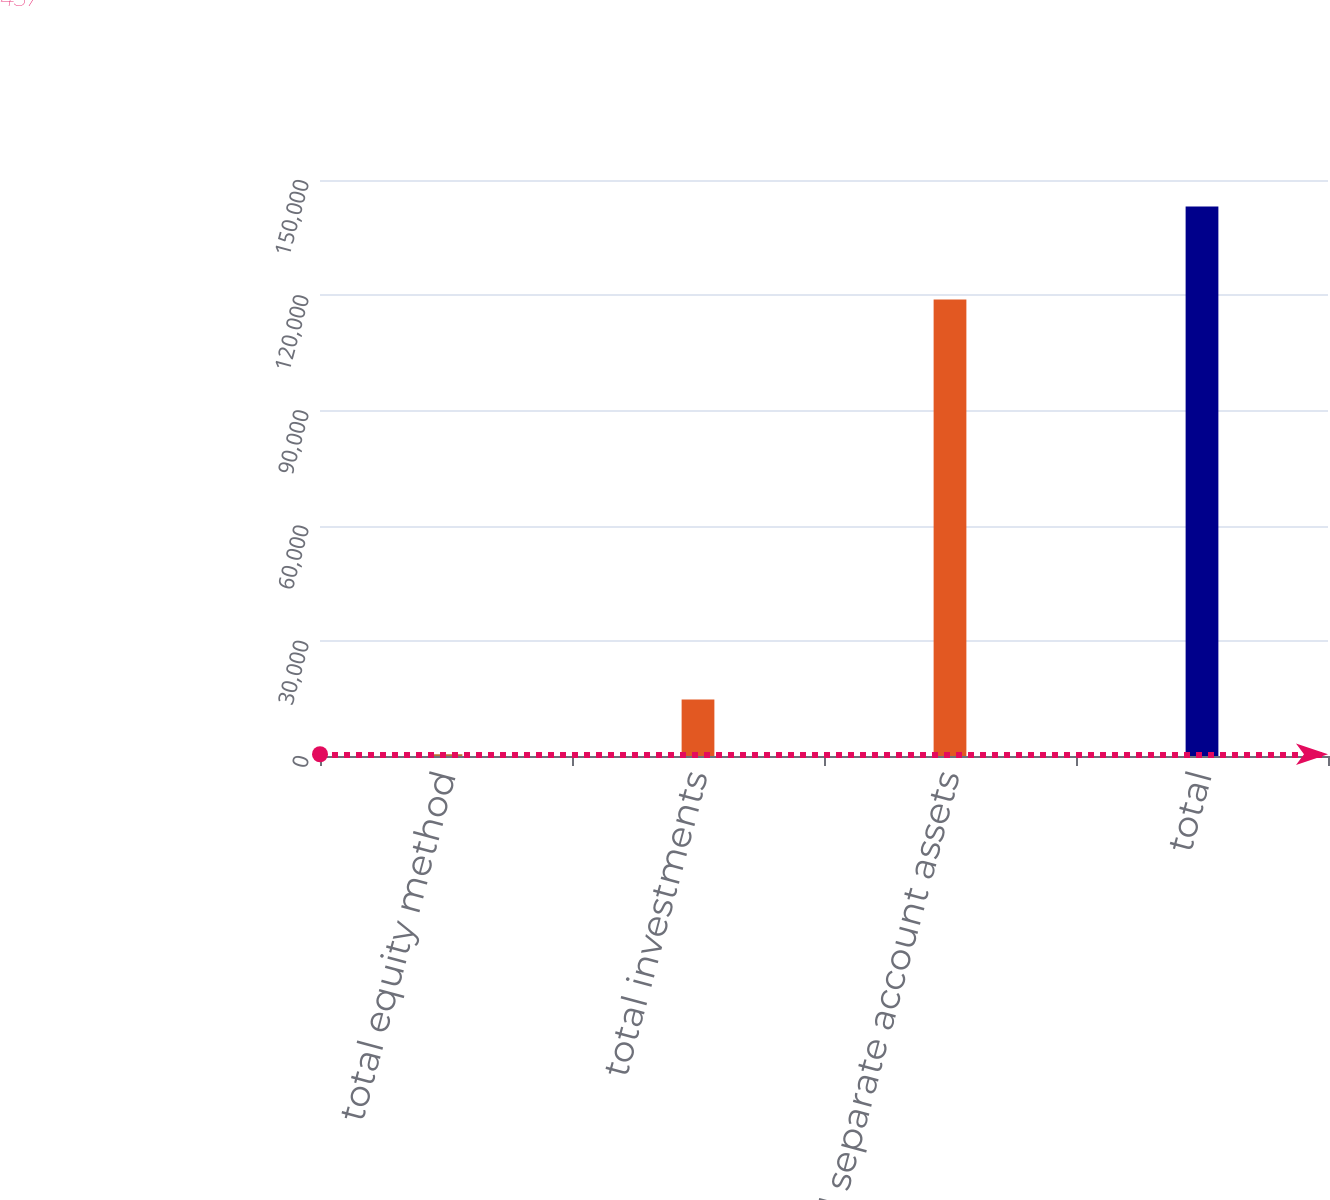<chart> <loc_0><loc_0><loc_500><loc_500><bar_chart><fcel>total equity method<fcel>total investments<fcel>total separate account assets<fcel>total<nl><fcel>457<fcel>14718.3<fcel>118871<fcel>143070<nl></chart> 